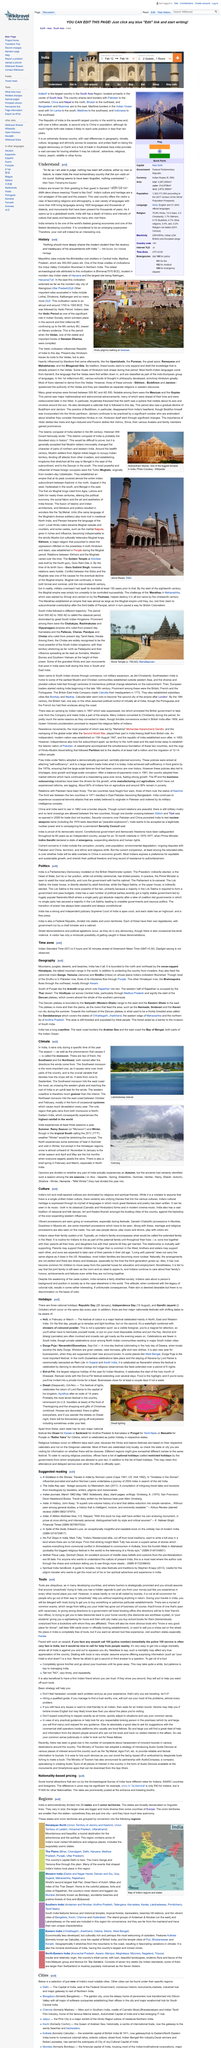Draw attention to some important aspects in this diagram. Atithi devo bhava" means "The guest is like God," and it is a declaration that honors the importance of hospitality and treating guests with respect and kindness. There are more than 438 living languages still present in the area. Mark Twain is famously quoted as having said, "What famous person quoted the first paragraph of this article? 